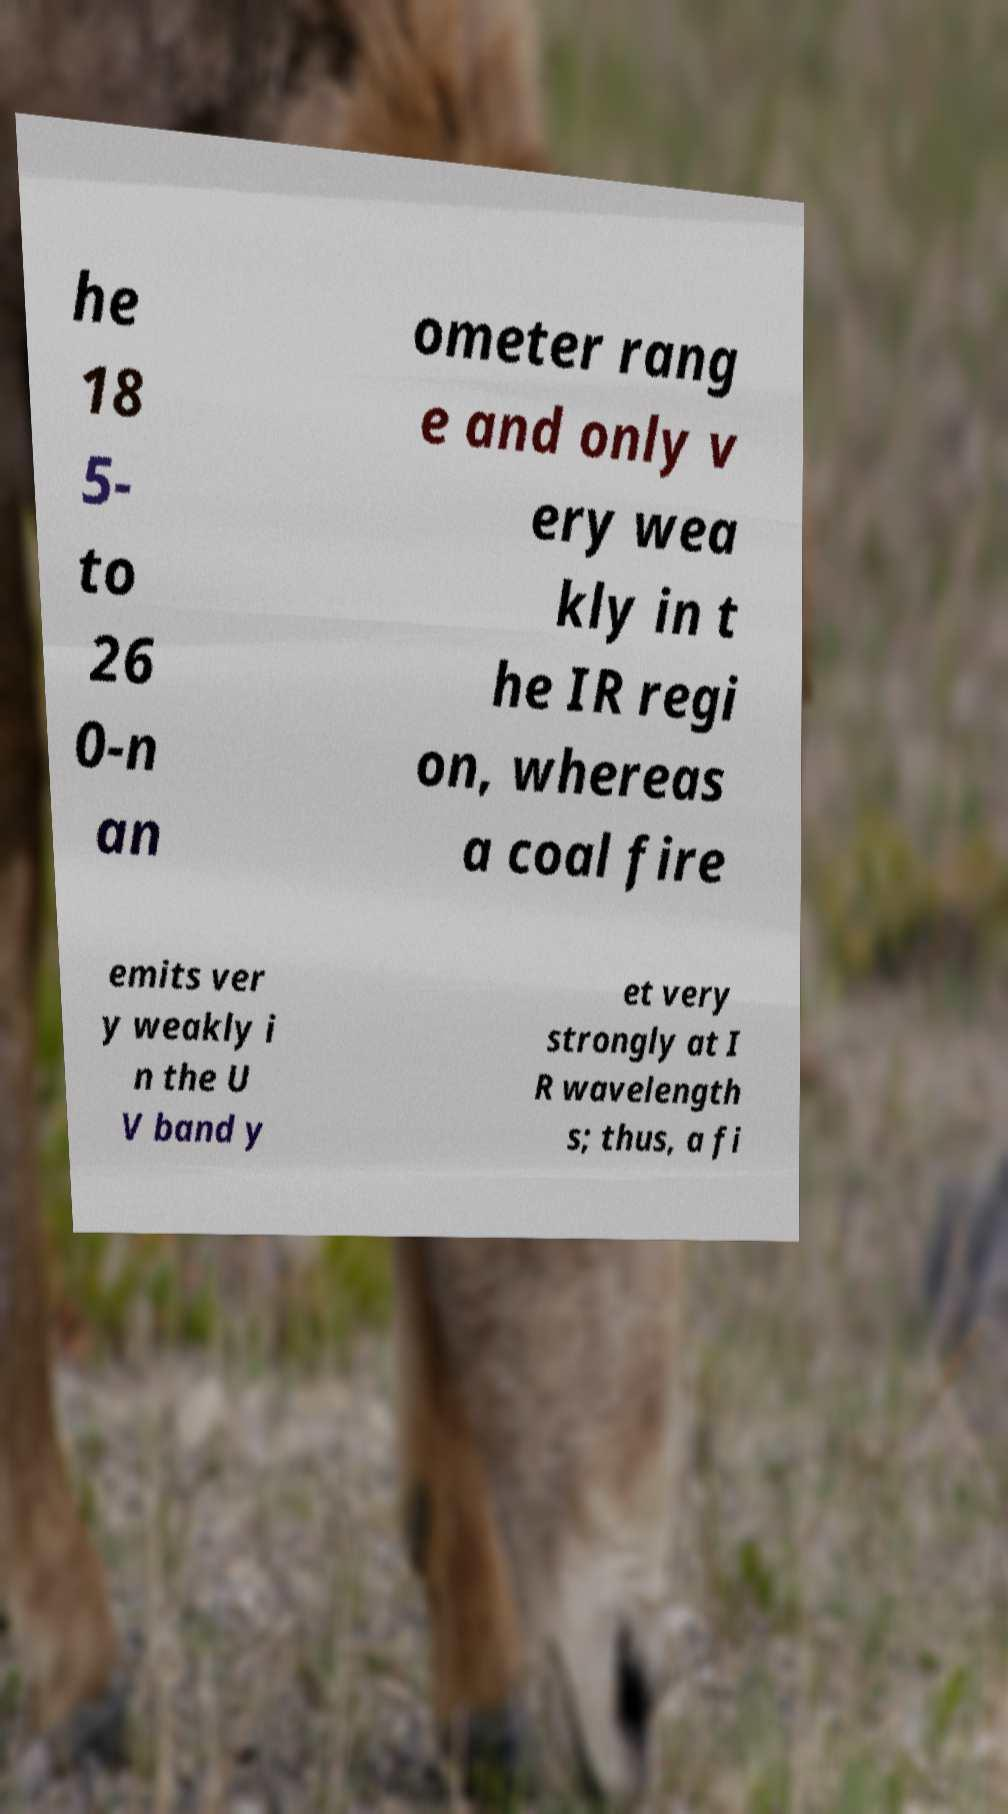What messages or text are displayed in this image? I need them in a readable, typed format. he 18 5- to 26 0-n an ometer rang e and only v ery wea kly in t he IR regi on, whereas a coal fire emits ver y weakly i n the U V band y et very strongly at I R wavelength s; thus, a fi 